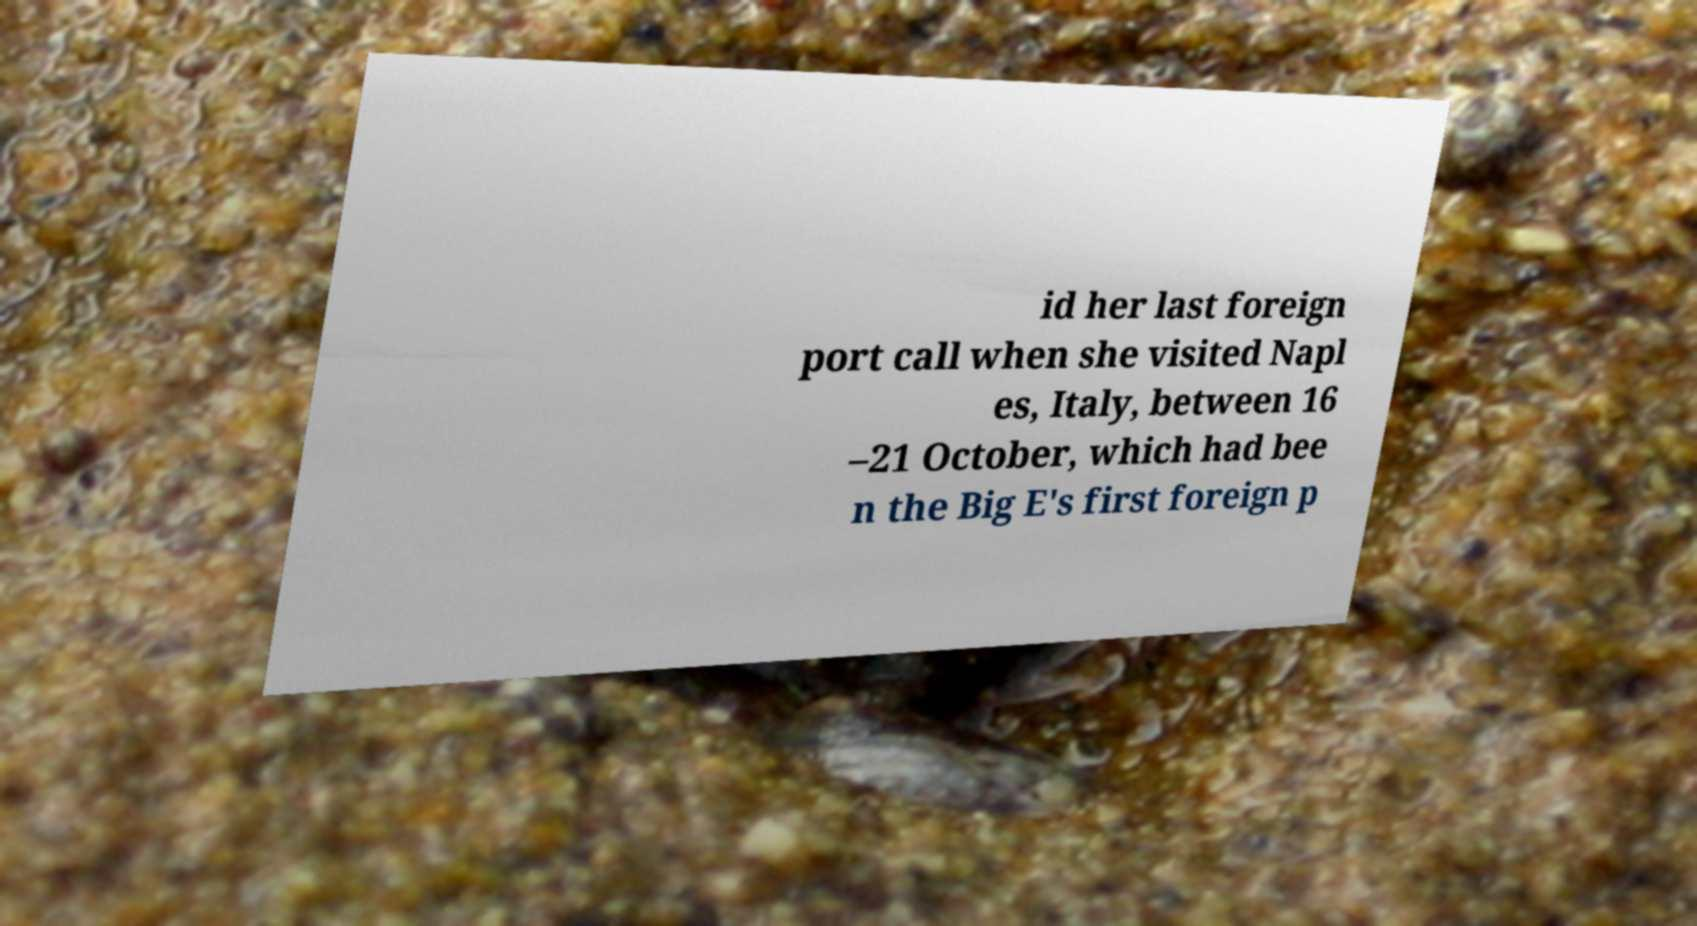What messages or text are displayed in this image? I need them in a readable, typed format. id her last foreign port call when she visited Napl es, Italy, between 16 –21 October, which had bee n the Big E's first foreign p 